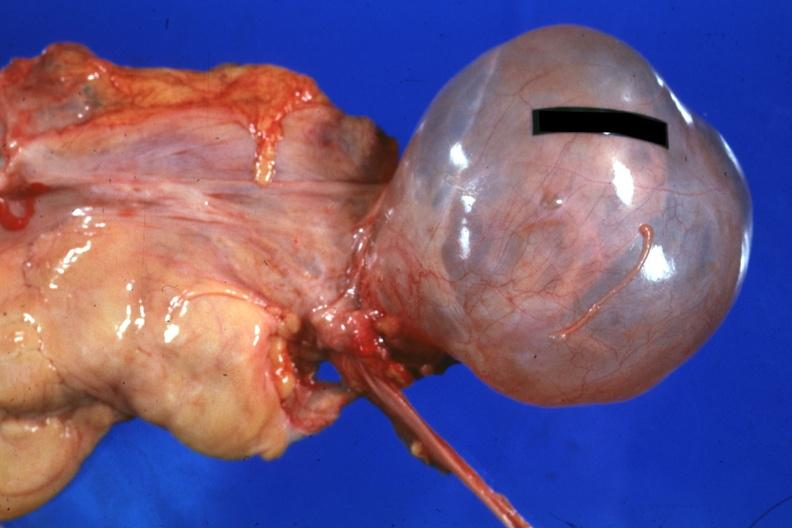s capillary present?
Answer the question using a single word or phrase. No 